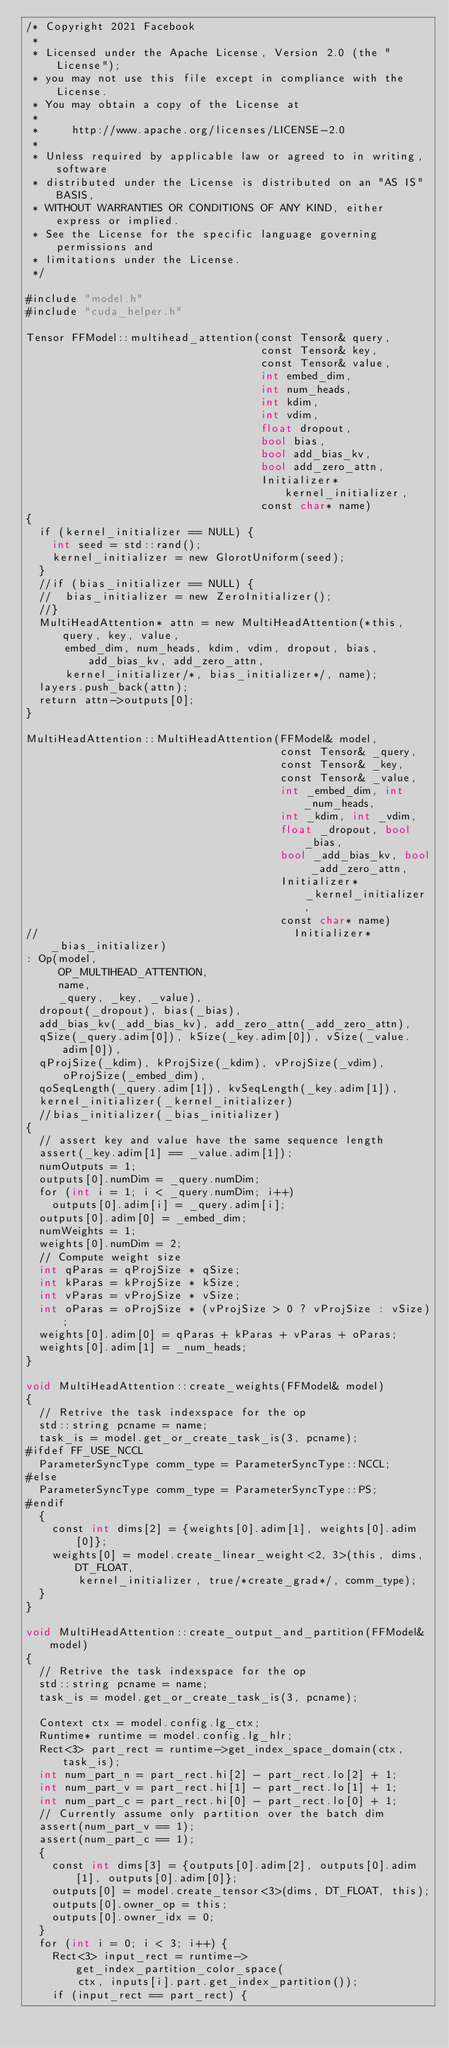Convert code to text. <code><loc_0><loc_0><loc_500><loc_500><_Cuda_>/* Copyright 2021 Facebook
 *
 * Licensed under the Apache License, Version 2.0 (the "License");
 * you may not use this file except in compliance with the License.
 * You may obtain a copy of the License at
 *
 *     http://www.apache.org/licenses/LICENSE-2.0
 *
 * Unless required by applicable law or agreed to in writing, software
 * distributed under the License is distributed on an "AS IS" BASIS,
 * WITHOUT WARRANTIES OR CONDITIONS OF ANY KIND, either express or implied.
 * See the License for the specific language governing permissions and
 * limitations under the License.
 */

#include "model.h"
#include "cuda_helper.h"

Tensor FFModel::multihead_attention(const Tensor& query,
                                    const Tensor& key,
                                    const Tensor& value,
                                    int embed_dim,
                                    int num_heads,
                                    int kdim,
                                    int vdim,
                                    float dropout,
                                    bool bias,
                                    bool add_bias_kv,
                                    bool add_zero_attn,
                                    Initializer* kernel_initializer,
                                    const char* name)
{
  if (kernel_initializer == NULL) {
    int seed = std::rand();
    kernel_initializer = new GlorotUniform(seed);
  }
  //if (bias_initializer == NULL) {
  //  bias_initializer = new ZeroInitializer();
  //}
  MultiHeadAttention* attn = new MultiHeadAttention(*this, query, key, value,
      embed_dim, num_heads, kdim, vdim, dropout, bias, add_bias_kv, add_zero_attn,
      kernel_initializer/*, bias_initializer*/, name);
  layers.push_back(attn);
  return attn->outputs[0];
}

MultiHeadAttention::MultiHeadAttention(FFModel& model,
                                       const Tensor& _query,
                                       const Tensor& _key,
                                       const Tensor& _value,
                                       int _embed_dim, int _num_heads,
                                       int _kdim, int _vdim,
                                       float _dropout, bool _bias,
                                       bool _add_bias_kv, bool _add_zero_attn,
                                       Initializer* _kernel_initializer,
                                       const char* name)
//                                       Initializer* _bias_initializer)
: Op(model,
     OP_MULTIHEAD_ATTENTION,
     name,
     _query, _key, _value),
  dropout(_dropout), bias(_bias),
  add_bias_kv(_add_bias_kv), add_zero_attn(_add_zero_attn),
  qSize(_query.adim[0]), kSize(_key.adim[0]), vSize(_value.adim[0]),
  qProjSize(_kdim), kProjSize(_kdim), vProjSize(_vdim), oProjSize(_embed_dim),
  qoSeqLength(_query.adim[1]), kvSeqLength(_key.adim[1]),
  kernel_initializer(_kernel_initializer)
  //bias_initializer(_bias_initializer)
{
  // assert key and value have the same sequence length
  assert(_key.adim[1] == _value.adim[1]);
  numOutputs = 1;
  outputs[0].numDim = _query.numDim;
  for (int i = 1; i < _query.numDim; i++)
    outputs[0].adim[i] = _query.adim[i];
  outputs[0].adim[0] = _embed_dim;
  numWeights = 1;
  weights[0].numDim = 2;
  // Compute weight size
  int qParas = qProjSize * qSize;
  int kParas = kProjSize * kSize;
  int vParas = vProjSize * vSize;
  int oParas = oProjSize * (vProjSize > 0 ? vProjSize : vSize);
  weights[0].adim[0] = qParas + kParas + vParas + oParas;
  weights[0].adim[1] = _num_heads;
}

void MultiHeadAttention::create_weights(FFModel& model)
{
  // Retrive the task indexspace for the op
  std::string pcname = name;
  task_is = model.get_or_create_task_is(3, pcname);
#ifdef FF_USE_NCCL
  ParameterSyncType comm_type = ParameterSyncType::NCCL;
#else
  ParameterSyncType comm_type = ParameterSyncType::PS;
#endif
  {
    const int dims[2] = {weights[0].adim[1], weights[0].adim[0]};
    weights[0] = model.create_linear_weight<2, 3>(this, dims, DT_FLOAT,
        kernel_initializer, true/*create_grad*/, comm_type);
  }
}

void MultiHeadAttention::create_output_and_partition(FFModel& model)
{
  // Retrive the task indexspace for the op
  std::string pcname = name;
  task_is = model.get_or_create_task_is(3, pcname);

  Context ctx = model.config.lg_ctx;
  Runtime* runtime = model.config.lg_hlr;
  Rect<3> part_rect = runtime->get_index_space_domain(ctx, task_is);
  int num_part_n = part_rect.hi[2] - part_rect.lo[2] + 1;
  int num_part_v = part_rect.hi[1] - part_rect.lo[1] + 1;
  int num_part_c = part_rect.hi[0] - part_rect.lo[0] + 1;
  // Currently assume only partition over the batch dim
  assert(num_part_v == 1);
  assert(num_part_c == 1);
  {
    const int dims[3] = {outputs[0].adim[2], outputs[0].adim[1], outputs[0].adim[0]};
    outputs[0] = model.create_tensor<3>(dims, DT_FLOAT, this);
    outputs[0].owner_op = this;
    outputs[0].owner_idx = 0;
  }
  for (int i = 0; i < 3; i++) {
    Rect<3> input_rect = runtime->get_index_partition_color_space(
        ctx, inputs[i].part.get_index_partition());
    if (input_rect == part_rect) {</code> 